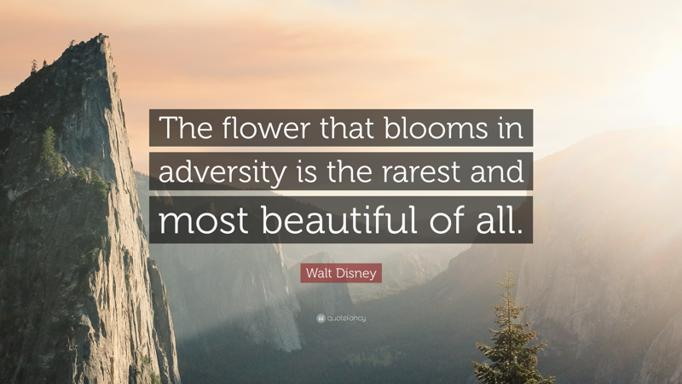How might this imagery of towering mountains and serene landscapes influence one's thoughts about challenges and achievements? This imagery of majestic mountains juxtaposed with serene landscapes can inspire individuals to view their challenges as part of a larger, beautiful journey. The daunting peaks represent the obstacles we encounter, while the calming nature around suggests a peace that comes with perseverance and achievement. Such scenes can motivate one to embrace challenges as opportunities for growth and personal achievement. 